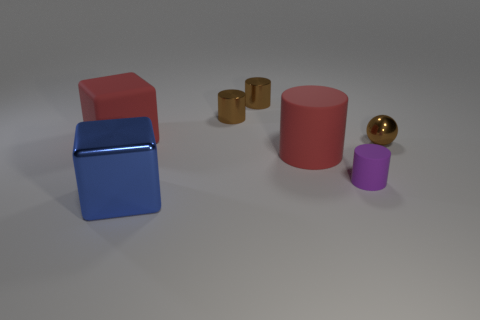The rubber object that is the same color as the rubber block is what shape?
Keep it short and to the point. Cylinder. Does the large cylinder have the same color as the matte thing that is on the left side of the large red rubber cylinder?
Provide a short and direct response. Yes. Are there any cylinders that have the same color as the ball?
Give a very brief answer. Yes. Does the big red cube have the same material as the tiny cylinder that is in front of the tiny shiny sphere?
Make the answer very short. Yes. Are there any brown objects that have the same material as the tiny brown ball?
Ensure brevity in your answer.  Yes. How many objects are shiny things behind the blue metallic thing or tiny things that are behind the purple cylinder?
Offer a very short reply. 3. Is the shape of the purple rubber object the same as the metal thing that is in front of the purple matte object?
Provide a short and direct response. No. How many other objects are there of the same shape as the purple rubber thing?
Offer a very short reply. 3. How many things are either metallic cubes or cylinders?
Your response must be concise. 5. Do the big cylinder and the large matte block have the same color?
Make the answer very short. Yes. 